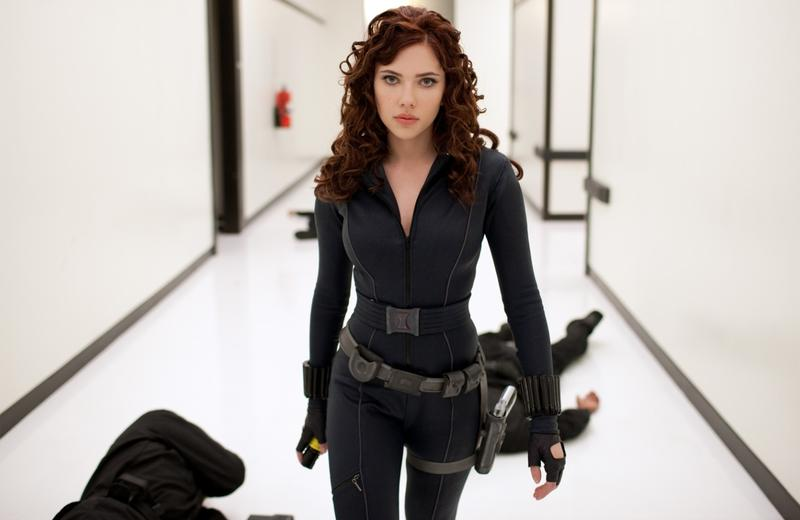If this character were to write a letter to a loved one after this moment, what might it say? Dear [Loved One],

Today was another battle in what feels like an endless war. As I walked through the stark white corridors, I couldn't help but think of you. I faced our adversaries bravely, and they now lie subdued behind me. Each step forward, I carry the hope that one day we will see the end of this turmoil. My resolve is strong, bolstered by thoughts of you. I am determined to create a safer world for us, where we can live without the shadows of conflict looming over us. Know that every action I take is with you in my heart. I miss you and hope to be reunited soon. Stay strong, my love.

With all my love,
[Character's Name] 